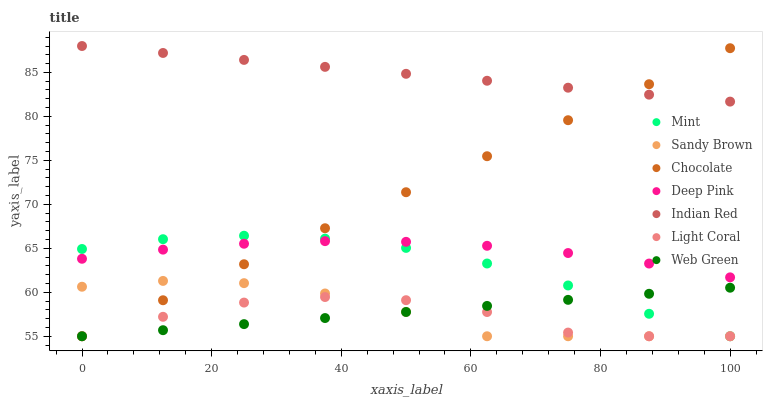Does Light Coral have the minimum area under the curve?
Answer yes or no. Yes. Does Indian Red have the maximum area under the curve?
Answer yes or no. Yes. Does Mint have the minimum area under the curve?
Answer yes or no. No. Does Mint have the maximum area under the curve?
Answer yes or no. No. Is Web Green the smoothest?
Answer yes or no. Yes. Is Light Coral the roughest?
Answer yes or no. Yes. Is Mint the smoothest?
Answer yes or no. No. Is Mint the roughest?
Answer yes or no. No. Does Mint have the lowest value?
Answer yes or no. Yes. Does Indian Red have the lowest value?
Answer yes or no. No. Does Indian Red have the highest value?
Answer yes or no. Yes. Does Mint have the highest value?
Answer yes or no. No. Is Web Green less than Deep Pink?
Answer yes or no. Yes. Is Indian Red greater than Web Green?
Answer yes or no. Yes. Does Sandy Brown intersect Mint?
Answer yes or no. Yes. Is Sandy Brown less than Mint?
Answer yes or no. No. Is Sandy Brown greater than Mint?
Answer yes or no. No. Does Web Green intersect Deep Pink?
Answer yes or no. No. 